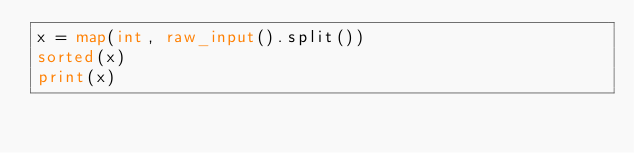Convert code to text. <code><loc_0><loc_0><loc_500><loc_500><_Python_>x = map(int, raw_input().split())
sorted(x)
print(x)</code> 